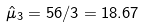<formula> <loc_0><loc_0><loc_500><loc_500>\hat { \mu } _ { 3 } = 5 6 / 3 = 1 8 . 6 7</formula> 